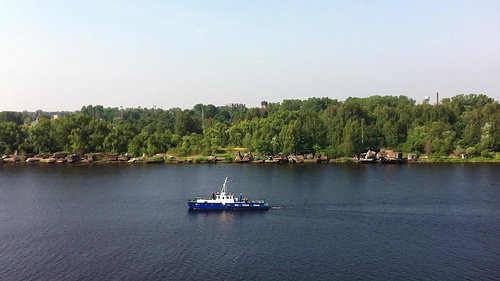Describe the environment surrounding the river. The river is bordered by thick green foliage, creating a serene and secluded atmosphere. These woods likely host a variety of wildlife and provide a natural habitat that enhances the river's ecological system. 